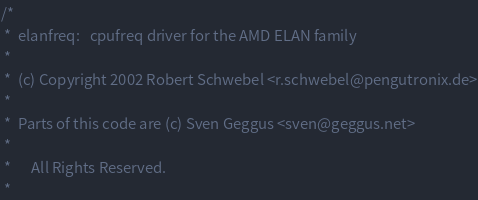Convert code to text. <code><loc_0><loc_0><loc_500><loc_500><_C_>/*
 *	elanfreq:	cpufreq driver for the AMD ELAN family
 *
 *	(c) Copyright 2002 Robert Schwebel <r.schwebel@pengutronix.de>
 *
 *	Parts of this code are (c) Sven Geggus <sven@geggus.net>
 *
 *      All Rights Reserved.
 *</code> 